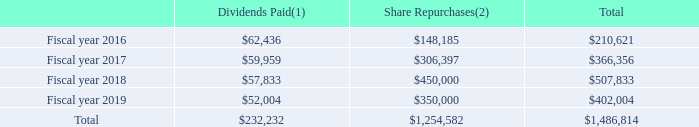Dividends and Share Repurchases
Following is a summary of the dividends and share repurchases for the fiscal years ended August 31, 2019, 2018, 2017 and 2016 (in thousands):
(1) The difference between dividends declared and dividends paid is due to dividend equivalents for unvested restricted stock units that are paid at the time the awards vest.
(2) Excludes commissions.
We currently expect to continue to declare and pay regular quarterly dividends of an amount similar to our past declarations. However, the declaration and payment of future dividends are discretionary and will be subject to determination by our Board each quarter following its review of our financial performance.
In June 2018, the Board authorized the repurchase of up to $350.0 million of our common stock. As of August 31, 2019, the total amount authorized by the Board of Directors had been repurchased.
In September 2019, the Board authorized the repurchase of up to $600.0 million of our common stock as part of a two-year capital allocation framework. From September 24, 2019 through October 14, 2019, we repurchased 874,475 shares, utilizing a total of $30.8 million of the $600.0 million authorized by the Board.
Which fiscal years does the table provide data of the dividends and share repurchases for? 2016, 2017, 2018, 2019. What were the dividends paid in 2016?
Answer scale should be: thousand. $62,436. What were the share repurchases in 2017?
Answer scale should be: thousand. $306,397. How many fiscal years had dividends paid that exceeded $60,000 thousand? 2016
Answer: 1. What was the change in share repurchases between 2016 and 2017?
Answer scale should be: thousand. $306,397-$148,185
Answer: 158212. What was the percentage change in dividends paid between 2018 and 2019?
Answer scale should be: percent. ($52,004-$57,833)/$57,833
Answer: -10.08. 